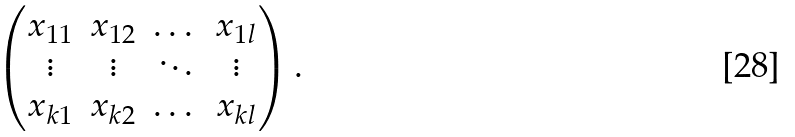<formula> <loc_0><loc_0><loc_500><loc_500>\begin{pmatrix} x _ { 1 1 } & x _ { 1 2 } & \dots & x _ { 1 l } \\ \vdots & \vdots & \ddots & \vdots \\ x _ { k 1 } & x _ { k 2 } & \dots & x _ { k l } \end{pmatrix} .</formula> 